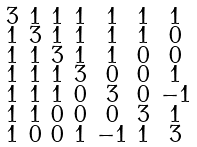<formula> <loc_0><loc_0><loc_500><loc_500>\begin{smallmatrix} 3 & 1 & 1 & 1 & 1 & 1 & 1 \\ 1 & 3 & 1 & 1 & 1 & 1 & 0 \\ 1 & 1 & 3 & 1 & 1 & 0 & 0 \\ 1 & 1 & 1 & 3 & 0 & 0 & 1 \\ 1 & 1 & 1 & 0 & 3 & 0 & - 1 \\ 1 & 1 & 0 & 0 & 0 & 3 & 1 \\ 1 & 0 & 0 & 1 & - 1 & 1 & 3 \end{smallmatrix}</formula> 